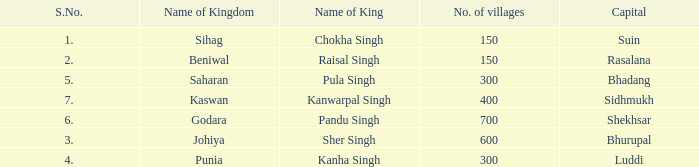Which kingdom has Suin as its capital? Sihag. 